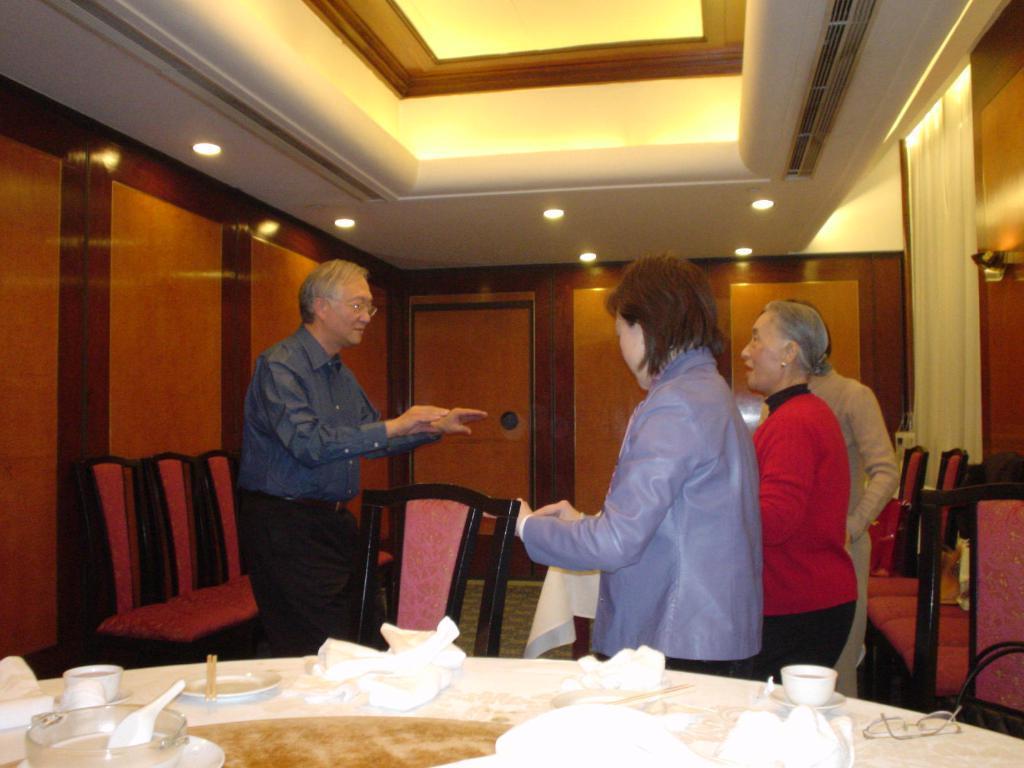Describe this image in one or two sentences. In this picture we can see four people one man is talking with three people, they are in the room, in front of them we can find a plate, bowls, cups, spectacles on the table, and also we can find couple of chairs and lights in the room. 